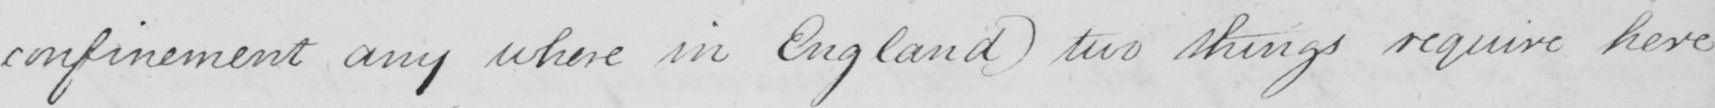Transcribe the text shown in this historical manuscript line. confinement any where in England two things require here 